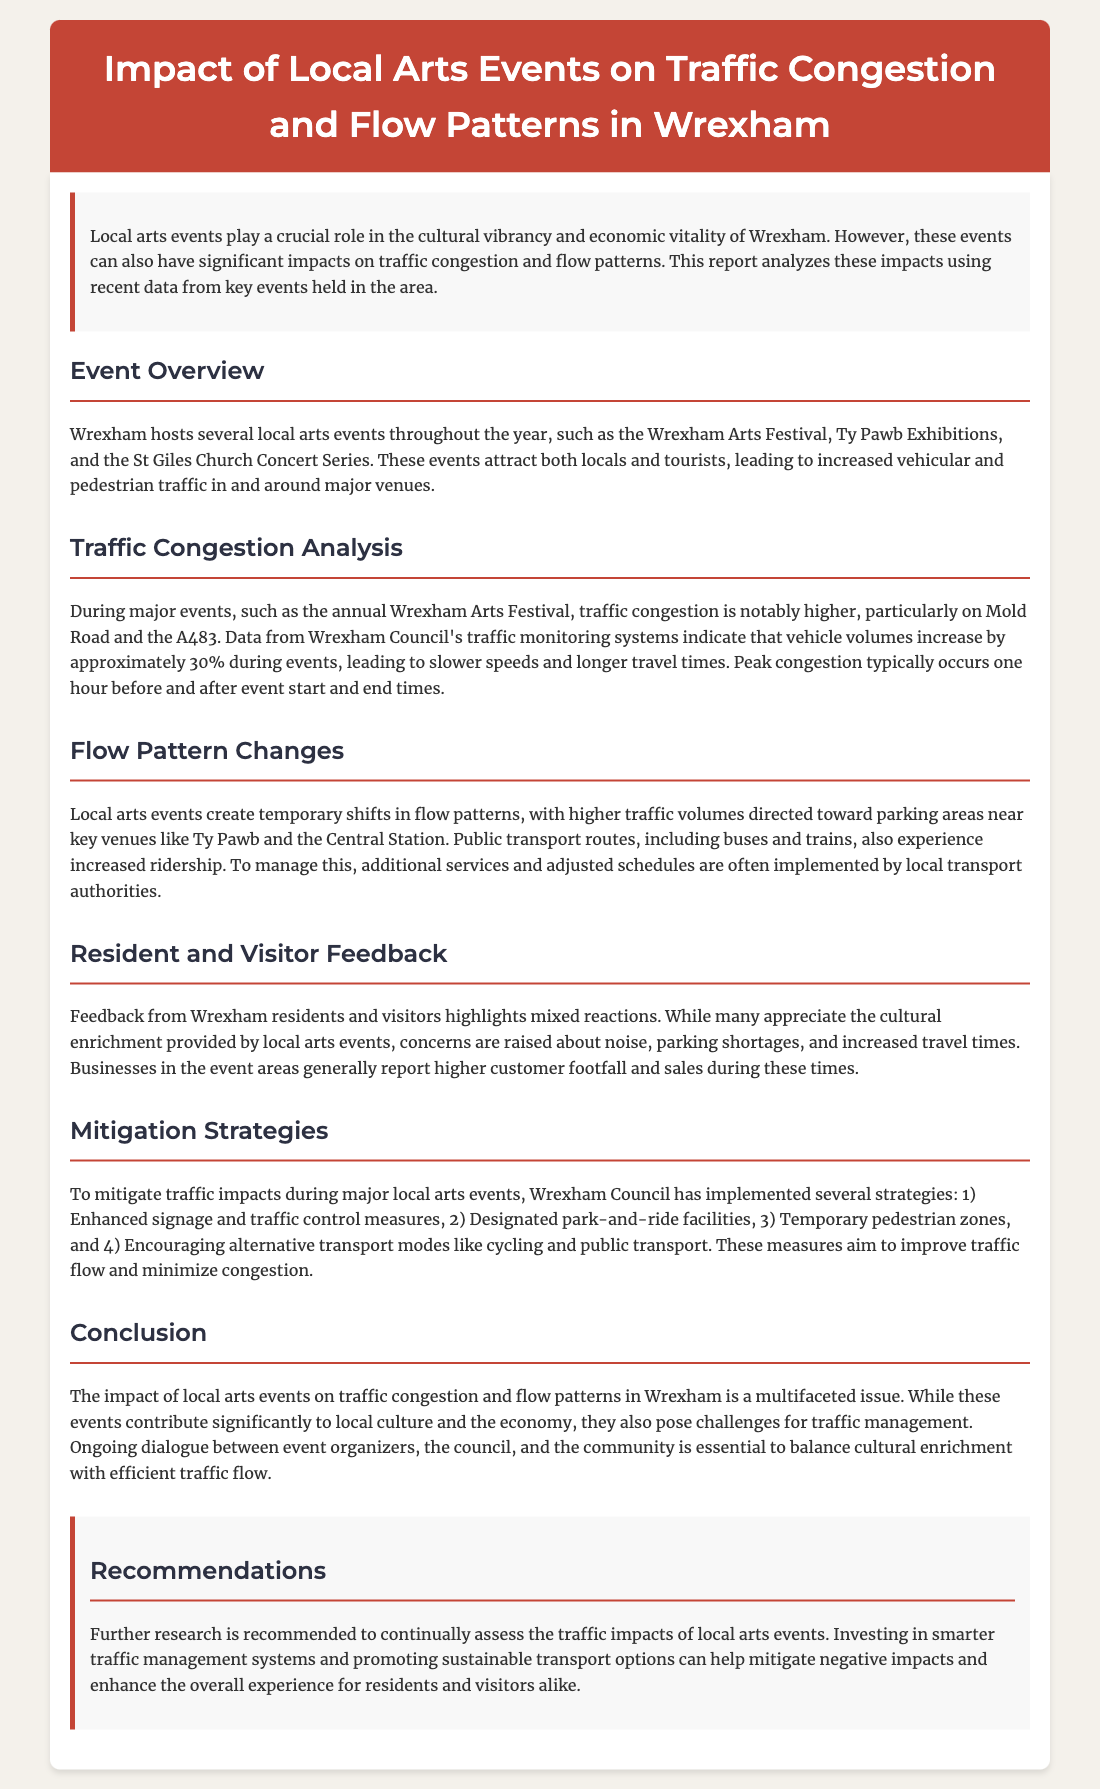What is the title of the report? The title of the report is found in the header section, which summarizes the main topic being analyzed.
Answer: Impact of Local Arts Events on Traffic Congestion and Flow Patterns in Wrexham What percentage increase in vehicle volumes occurs during events? The report provides specific statistics on traffic changes during events, indicating the impact on vehicle volumes.
Answer: 30% During which event is congestion notably higher? The document mentions a specific annual event that has a significant impact on traffic in the area.
Answer: Wrexham Arts Festival What time do peak congestion levels typically occur? The report details the times when congestion is most severe, based on event schedules.
Answer: One hour before and after event start and end times What are two mitigation strategies employed by Wrexham Council? The report outlines several strategies to manage traffic during local arts events, highlighting some specific measures taken.
Answer: Enhanced signage and designated park-and-ride facilities What is a common feedback theme from residents regarding events? Feedback is discussed, including various sentiments expressed by the community in response to local arts activities.
Answer: Noise What types of venues draw increased traffic during events? The document identifies specific locations that see a rise in traffic due to local arts events.
Answer: Ty Pawb and Central Station What are the recommendations for traffic management? The report concludes with suggestions aimed at improving future traffic flow in relation to events, emphasizing the need for continued assessment.
Answer: Further research and smarter traffic management systems 